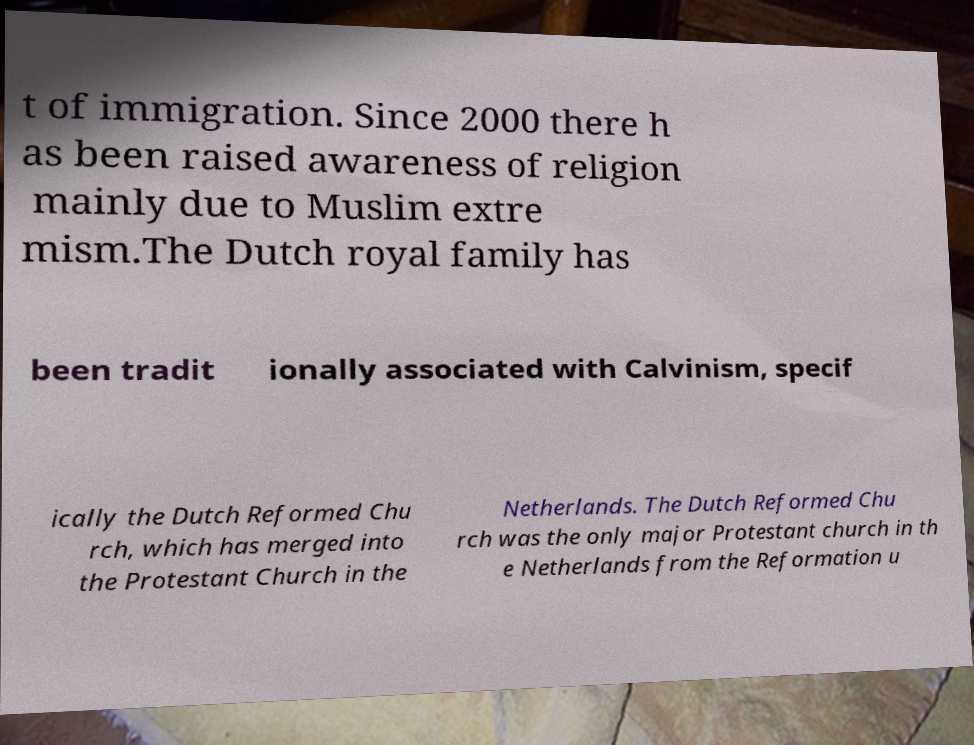Can you read and provide the text displayed in the image?This photo seems to have some interesting text. Can you extract and type it out for me? t of immigration. Since 2000 there h as been raised awareness of religion mainly due to Muslim extre mism.The Dutch royal family has been tradit ionally associated with Calvinism, specif ically the Dutch Reformed Chu rch, which has merged into the Protestant Church in the Netherlands. The Dutch Reformed Chu rch was the only major Protestant church in th e Netherlands from the Reformation u 